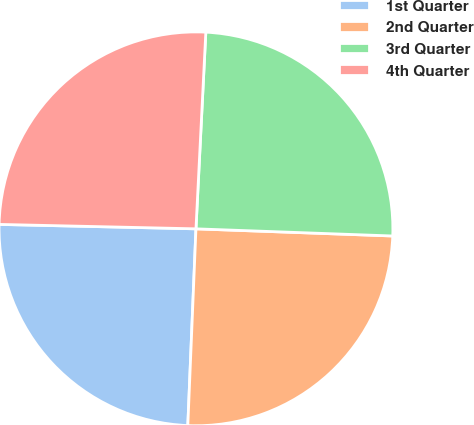<chart> <loc_0><loc_0><loc_500><loc_500><pie_chart><fcel>1st Quarter<fcel>2nd Quarter<fcel>3rd Quarter<fcel>4th Quarter<nl><fcel>24.7%<fcel>25.08%<fcel>24.78%<fcel>25.44%<nl></chart> 